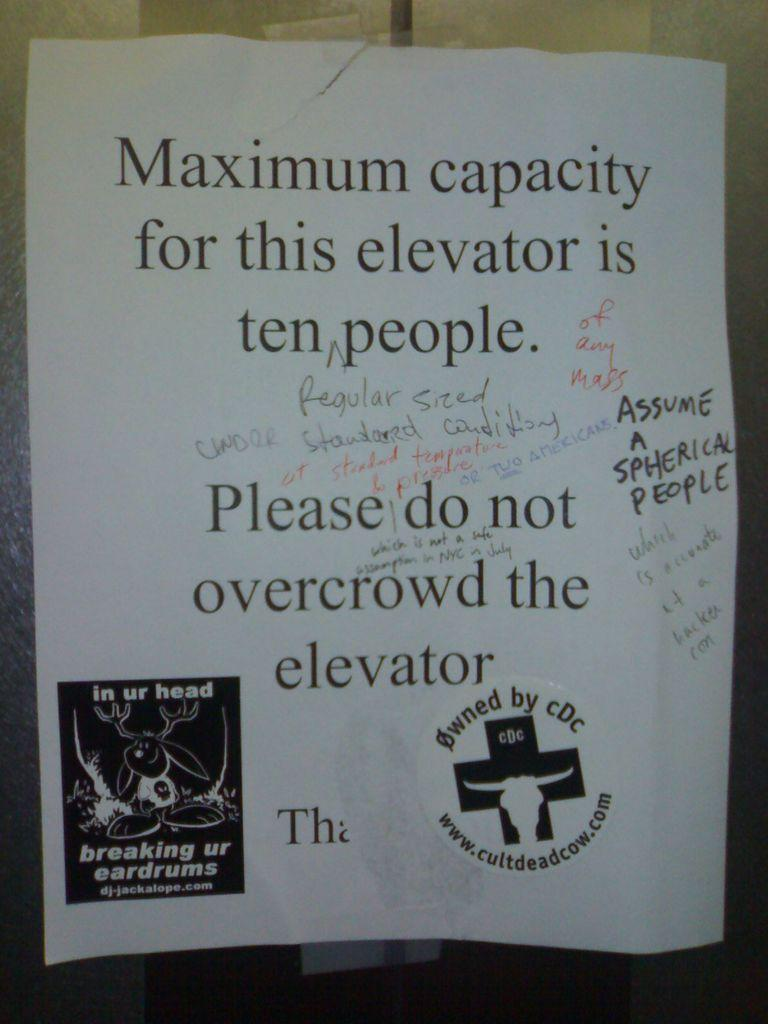<image>
Summarize the visual content of the image. Paper that have maximum capacity for this elevator is ten people 